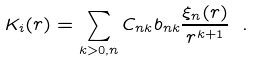Convert formula to latex. <formula><loc_0><loc_0><loc_500><loc_500>K _ { i } ( r ) = \sum _ { k > 0 , n } C _ { n k } b _ { n k } \frac { \xi _ { n } ( r ) } { r ^ { k + 1 } } \ .</formula> 